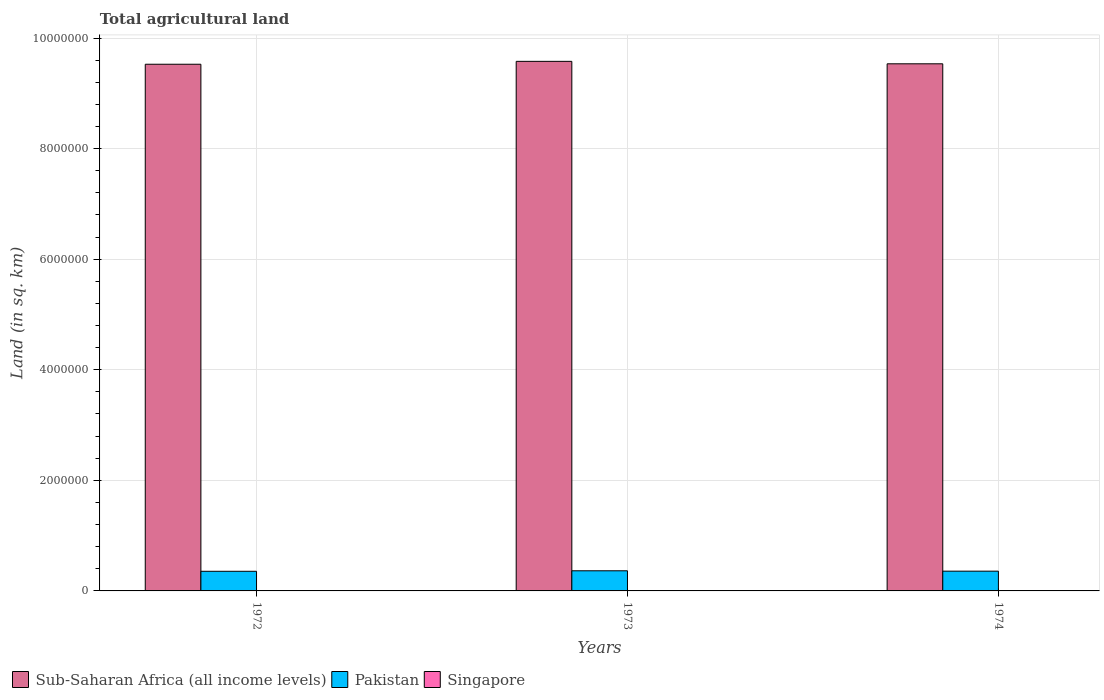Are the number of bars per tick equal to the number of legend labels?
Your answer should be compact. Yes. Are the number of bars on each tick of the X-axis equal?
Your response must be concise. Yes. How many bars are there on the 2nd tick from the left?
Provide a succinct answer. 3. In how many cases, is the number of bars for a given year not equal to the number of legend labels?
Your answer should be compact. 0. What is the total agricultural land in Pakistan in 1973?
Your answer should be very brief. 3.64e+05. Across all years, what is the maximum total agricultural land in Sub-Saharan Africa (all income levels)?
Offer a terse response. 9.58e+06. Across all years, what is the minimum total agricultural land in Sub-Saharan Africa (all income levels)?
Make the answer very short. 9.53e+06. In which year was the total agricultural land in Pakistan maximum?
Ensure brevity in your answer.  1973. In which year was the total agricultural land in Singapore minimum?
Provide a succinct answer. 1974. What is the total total agricultural land in Sub-Saharan Africa (all income levels) in the graph?
Ensure brevity in your answer.  2.86e+07. What is the difference between the total agricultural land in Singapore in 1972 and that in 1973?
Make the answer very short. 0. What is the difference between the total agricultural land in Sub-Saharan Africa (all income levels) in 1973 and the total agricultural land in Pakistan in 1974?
Provide a succinct answer. 9.22e+06. What is the average total agricultural land in Pakistan per year?
Your answer should be very brief. 3.59e+05. In the year 1972, what is the difference between the total agricultural land in Pakistan and total agricultural land in Singapore?
Offer a terse response. 3.55e+05. In how many years, is the total agricultural land in Singapore greater than 1200000 sq.km?
Keep it short and to the point. 0. What is the ratio of the total agricultural land in Sub-Saharan Africa (all income levels) in 1972 to that in 1974?
Provide a succinct answer. 1. What is the difference between the highest and the second highest total agricultural land in Pakistan?
Provide a short and direct response. 6600. What is the difference between the highest and the lowest total agricultural land in Pakistan?
Provide a succinct answer. 8950. Is the sum of the total agricultural land in Pakistan in 1972 and 1974 greater than the maximum total agricultural land in Sub-Saharan Africa (all income levels) across all years?
Give a very brief answer. No. What does the 2nd bar from the right in 1974 represents?
Keep it short and to the point. Pakistan. Is it the case that in every year, the sum of the total agricultural land in Sub-Saharan Africa (all income levels) and total agricultural land in Singapore is greater than the total agricultural land in Pakistan?
Your response must be concise. Yes. How many bars are there?
Provide a succinct answer. 9. Does the graph contain any zero values?
Make the answer very short. No. Does the graph contain grids?
Your response must be concise. Yes. How many legend labels are there?
Your answer should be compact. 3. What is the title of the graph?
Your answer should be very brief. Total agricultural land. Does "Guatemala" appear as one of the legend labels in the graph?
Keep it short and to the point. No. What is the label or title of the X-axis?
Offer a terse response. Years. What is the label or title of the Y-axis?
Your answer should be compact. Land (in sq. km). What is the Land (in sq. km) in Sub-Saharan Africa (all income levels) in 1972?
Your answer should be very brief. 9.53e+06. What is the Land (in sq. km) of Pakistan in 1972?
Offer a very short reply. 3.55e+05. What is the Land (in sq. km) of Singapore in 1972?
Your answer should be very brief. 110. What is the Land (in sq. km) in Sub-Saharan Africa (all income levels) in 1973?
Your answer should be compact. 9.58e+06. What is the Land (in sq. km) in Pakistan in 1973?
Your response must be concise. 3.64e+05. What is the Land (in sq. km) in Singapore in 1973?
Ensure brevity in your answer.  110. What is the Land (in sq. km) in Sub-Saharan Africa (all income levels) in 1974?
Provide a short and direct response. 9.53e+06. What is the Land (in sq. km) in Pakistan in 1974?
Ensure brevity in your answer.  3.57e+05. What is the Land (in sq. km) in Singapore in 1974?
Give a very brief answer. 90. Across all years, what is the maximum Land (in sq. km) of Sub-Saharan Africa (all income levels)?
Provide a succinct answer. 9.58e+06. Across all years, what is the maximum Land (in sq. km) in Pakistan?
Your response must be concise. 3.64e+05. Across all years, what is the maximum Land (in sq. km) of Singapore?
Make the answer very short. 110. Across all years, what is the minimum Land (in sq. km) in Sub-Saharan Africa (all income levels)?
Offer a very short reply. 9.53e+06. Across all years, what is the minimum Land (in sq. km) of Pakistan?
Make the answer very short. 3.55e+05. What is the total Land (in sq. km) of Sub-Saharan Africa (all income levels) in the graph?
Make the answer very short. 2.86e+07. What is the total Land (in sq. km) in Pakistan in the graph?
Keep it short and to the point. 1.08e+06. What is the total Land (in sq. km) in Singapore in the graph?
Provide a short and direct response. 310. What is the difference between the Land (in sq. km) of Sub-Saharan Africa (all income levels) in 1972 and that in 1973?
Keep it short and to the point. -5.23e+04. What is the difference between the Land (in sq. km) of Pakistan in 1972 and that in 1973?
Keep it short and to the point. -8950. What is the difference between the Land (in sq. km) of Singapore in 1972 and that in 1973?
Make the answer very short. 0. What is the difference between the Land (in sq. km) of Sub-Saharan Africa (all income levels) in 1972 and that in 1974?
Ensure brevity in your answer.  -8070. What is the difference between the Land (in sq. km) of Pakistan in 1972 and that in 1974?
Ensure brevity in your answer.  -2350. What is the difference between the Land (in sq. km) in Singapore in 1972 and that in 1974?
Keep it short and to the point. 20. What is the difference between the Land (in sq. km) in Sub-Saharan Africa (all income levels) in 1973 and that in 1974?
Provide a short and direct response. 4.42e+04. What is the difference between the Land (in sq. km) of Pakistan in 1973 and that in 1974?
Your answer should be very brief. 6600. What is the difference between the Land (in sq. km) of Sub-Saharan Africa (all income levels) in 1972 and the Land (in sq. km) of Pakistan in 1973?
Your response must be concise. 9.16e+06. What is the difference between the Land (in sq. km) in Sub-Saharan Africa (all income levels) in 1972 and the Land (in sq. km) in Singapore in 1973?
Keep it short and to the point. 9.53e+06. What is the difference between the Land (in sq. km) in Pakistan in 1972 and the Land (in sq. km) in Singapore in 1973?
Offer a terse response. 3.55e+05. What is the difference between the Land (in sq. km) of Sub-Saharan Africa (all income levels) in 1972 and the Land (in sq. km) of Pakistan in 1974?
Keep it short and to the point. 9.17e+06. What is the difference between the Land (in sq. km) in Sub-Saharan Africa (all income levels) in 1972 and the Land (in sq. km) in Singapore in 1974?
Provide a short and direct response. 9.53e+06. What is the difference between the Land (in sq. km) of Pakistan in 1972 and the Land (in sq. km) of Singapore in 1974?
Give a very brief answer. 3.55e+05. What is the difference between the Land (in sq. km) of Sub-Saharan Africa (all income levels) in 1973 and the Land (in sq. km) of Pakistan in 1974?
Offer a terse response. 9.22e+06. What is the difference between the Land (in sq. km) in Sub-Saharan Africa (all income levels) in 1973 and the Land (in sq. km) in Singapore in 1974?
Your response must be concise. 9.58e+06. What is the difference between the Land (in sq. km) of Pakistan in 1973 and the Land (in sq. km) of Singapore in 1974?
Make the answer very short. 3.64e+05. What is the average Land (in sq. km) in Sub-Saharan Africa (all income levels) per year?
Give a very brief answer. 9.55e+06. What is the average Land (in sq. km) of Pakistan per year?
Your answer should be compact. 3.59e+05. What is the average Land (in sq. km) in Singapore per year?
Ensure brevity in your answer.  103.33. In the year 1972, what is the difference between the Land (in sq. km) of Sub-Saharan Africa (all income levels) and Land (in sq. km) of Pakistan?
Provide a succinct answer. 9.17e+06. In the year 1972, what is the difference between the Land (in sq. km) in Sub-Saharan Africa (all income levels) and Land (in sq. km) in Singapore?
Ensure brevity in your answer.  9.53e+06. In the year 1972, what is the difference between the Land (in sq. km) in Pakistan and Land (in sq. km) in Singapore?
Your response must be concise. 3.55e+05. In the year 1973, what is the difference between the Land (in sq. km) of Sub-Saharan Africa (all income levels) and Land (in sq. km) of Pakistan?
Your answer should be compact. 9.21e+06. In the year 1973, what is the difference between the Land (in sq. km) of Sub-Saharan Africa (all income levels) and Land (in sq. km) of Singapore?
Give a very brief answer. 9.58e+06. In the year 1973, what is the difference between the Land (in sq. km) in Pakistan and Land (in sq. km) in Singapore?
Your answer should be very brief. 3.64e+05. In the year 1974, what is the difference between the Land (in sq. km) of Sub-Saharan Africa (all income levels) and Land (in sq. km) of Pakistan?
Give a very brief answer. 9.18e+06. In the year 1974, what is the difference between the Land (in sq. km) of Sub-Saharan Africa (all income levels) and Land (in sq. km) of Singapore?
Make the answer very short. 9.53e+06. In the year 1974, what is the difference between the Land (in sq. km) of Pakistan and Land (in sq. km) of Singapore?
Your answer should be compact. 3.57e+05. What is the ratio of the Land (in sq. km) in Sub-Saharan Africa (all income levels) in 1972 to that in 1973?
Your answer should be very brief. 0.99. What is the ratio of the Land (in sq. km) in Pakistan in 1972 to that in 1973?
Make the answer very short. 0.98. What is the ratio of the Land (in sq. km) in Singapore in 1972 to that in 1973?
Your answer should be very brief. 1. What is the ratio of the Land (in sq. km) of Pakistan in 1972 to that in 1974?
Your answer should be very brief. 0.99. What is the ratio of the Land (in sq. km) in Singapore in 1972 to that in 1974?
Your response must be concise. 1.22. What is the ratio of the Land (in sq. km) of Sub-Saharan Africa (all income levels) in 1973 to that in 1974?
Your response must be concise. 1. What is the ratio of the Land (in sq. km) in Pakistan in 1973 to that in 1974?
Your answer should be very brief. 1.02. What is the ratio of the Land (in sq. km) of Singapore in 1973 to that in 1974?
Offer a very short reply. 1.22. What is the difference between the highest and the second highest Land (in sq. km) in Sub-Saharan Africa (all income levels)?
Your answer should be very brief. 4.42e+04. What is the difference between the highest and the second highest Land (in sq. km) of Pakistan?
Offer a terse response. 6600. What is the difference between the highest and the lowest Land (in sq. km) of Sub-Saharan Africa (all income levels)?
Make the answer very short. 5.23e+04. What is the difference between the highest and the lowest Land (in sq. km) in Pakistan?
Provide a short and direct response. 8950. What is the difference between the highest and the lowest Land (in sq. km) of Singapore?
Provide a succinct answer. 20. 